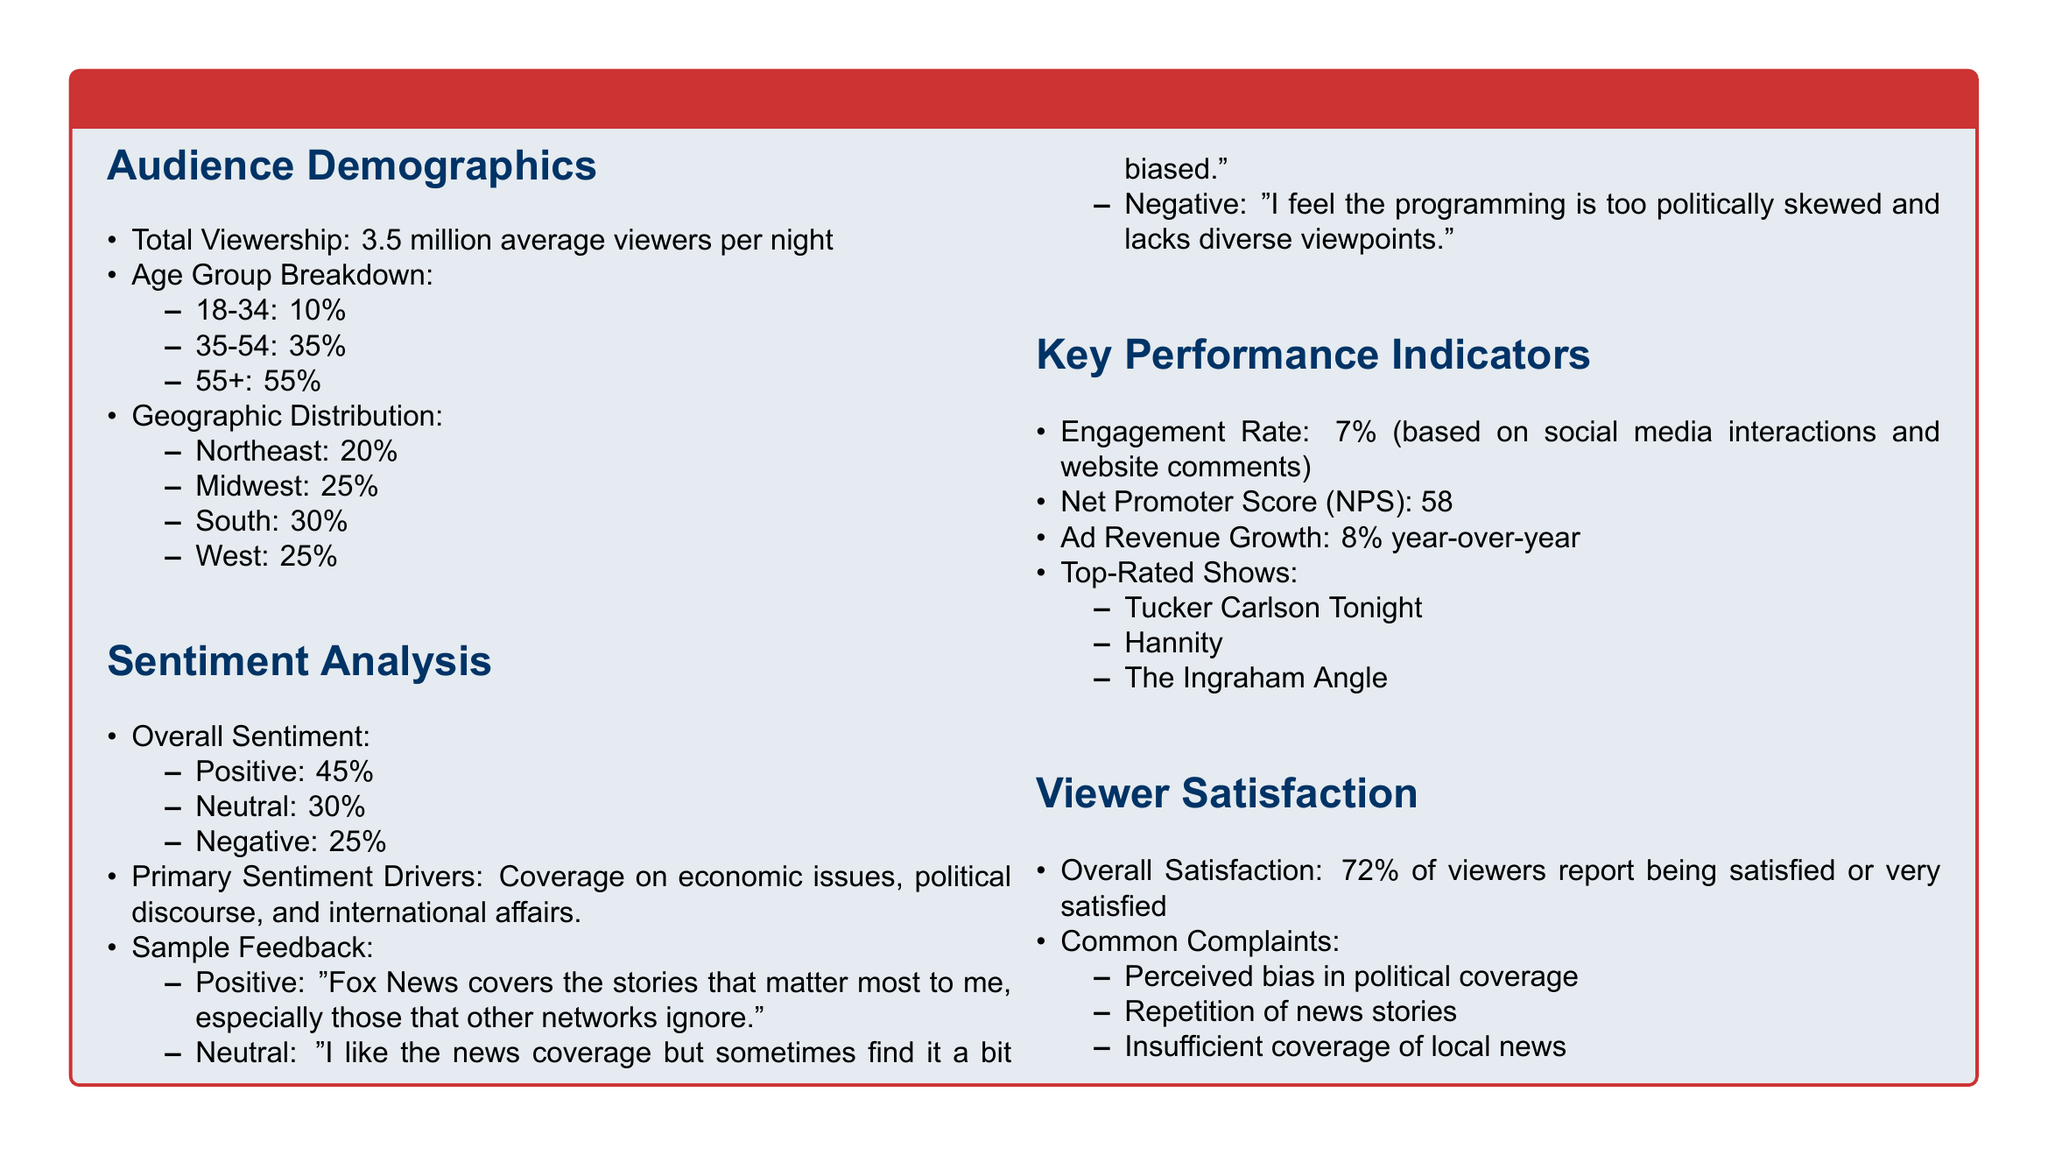What is the total viewership per night? The total viewership figure is provided directly in the document as the average number of viewers watching Fox News in the evening.
Answer: 3.5 million What percentage of the audience is aged 55 and older? This is found in the age group breakdown where demographics are given, specifically regarding the 55+ age category.
Answer: 55% What is the overall viewer satisfaction percentage? Overall satisfaction is stated as a percentage of viewers reporting satisfaction or high satisfaction in the viewer satisfaction section.
Answer: 72% What is the engagement rate for Fox News evening programming? The engagement rate is listed under key performance indicators and describes the percentage based on social media interactions and comments.
Answer: 7% Which show is listed as the top-rated? The top-rated shows are mentioned under key performance indicators, and the first example is provided.
Answer: Tucker Carlson Tonight Which region has the highest percentage of viewership? This information is found in the geographic distribution of the audience, indicating which area has the largest share.
Answer: South What percentage of feedback was classified as positive? This is detailed in the sentiment analysis section indicating the overall sentiment categorization.
Answer: 45% What are common complaints from viewers? The common complaints are listed in the viewer satisfaction section and highlight the key issues raised by the audience.
Answer: Perceived bias in political coverage What is the net promoter score for Fox News evening programming? The net promoter score is provided as a specific metric under key performance indicators in the document.
Answer: 58 